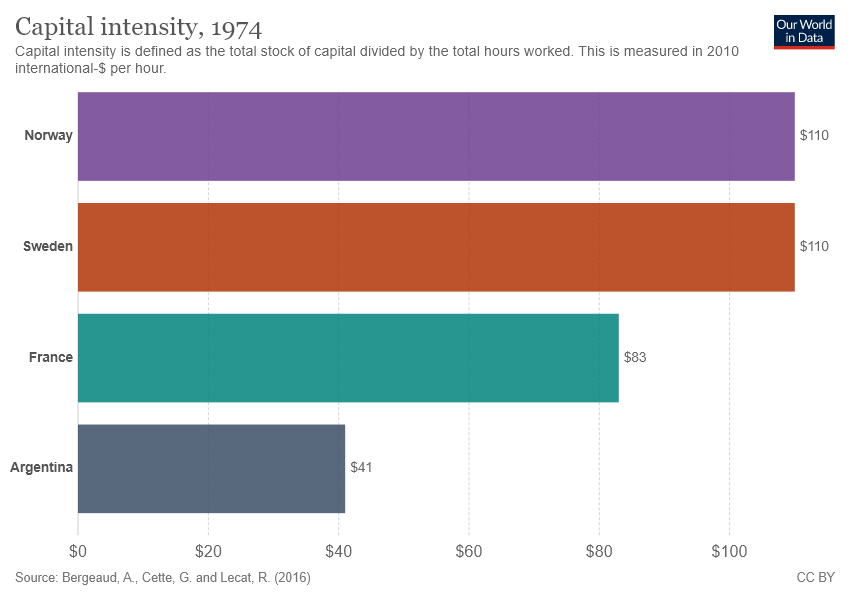Mention a couple of crucial points in this snapshot. The sum of the smallest two bars is greater than the value of the largest bar. There are 4 bars in the graph. 